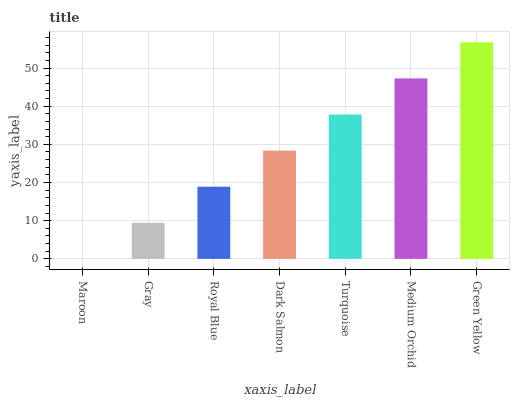Is Maroon the minimum?
Answer yes or no. Yes. Is Green Yellow the maximum?
Answer yes or no. Yes. Is Gray the minimum?
Answer yes or no. No. Is Gray the maximum?
Answer yes or no. No. Is Gray greater than Maroon?
Answer yes or no. Yes. Is Maroon less than Gray?
Answer yes or no. Yes. Is Maroon greater than Gray?
Answer yes or no. No. Is Gray less than Maroon?
Answer yes or no. No. Is Dark Salmon the high median?
Answer yes or no. Yes. Is Dark Salmon the low median?
Answer yes or no. Yes. Is Royal Blue the high median?
Answer yes or no. No. Is Green Yellow the low median?
Answer yes or no. No. 